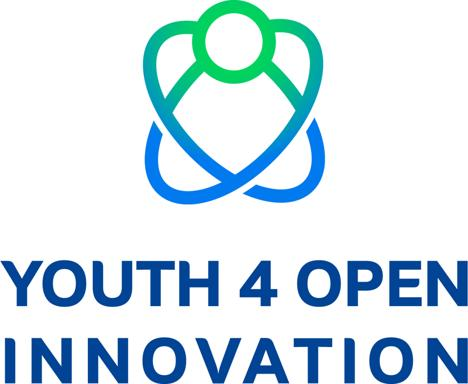How does the design of this logo relate to its intended audience? The logo's design is aimed at resonating with the youth, as it embodies energy, dynamism, and a forward-thinking mindset. The sleek and fluid lines imply adaptability, and the bold typeface ensures that the concept of 'open innovation' is unmistakably communicated. This combination aims to inspire and attract the younger generation to be actively involved in collaborative and open approaches to innovation. Could this logo be effective in different cultural contexts? The logo's use of universal symbols like the figure and the emphasis on connectivity suggests that it's designed to have cross-cultural appeal. Its straightforward and non-complex imagery aims to be easily recognizable and relatable, fostering a sense of community and shared goals across diverse cultural landscapes. 